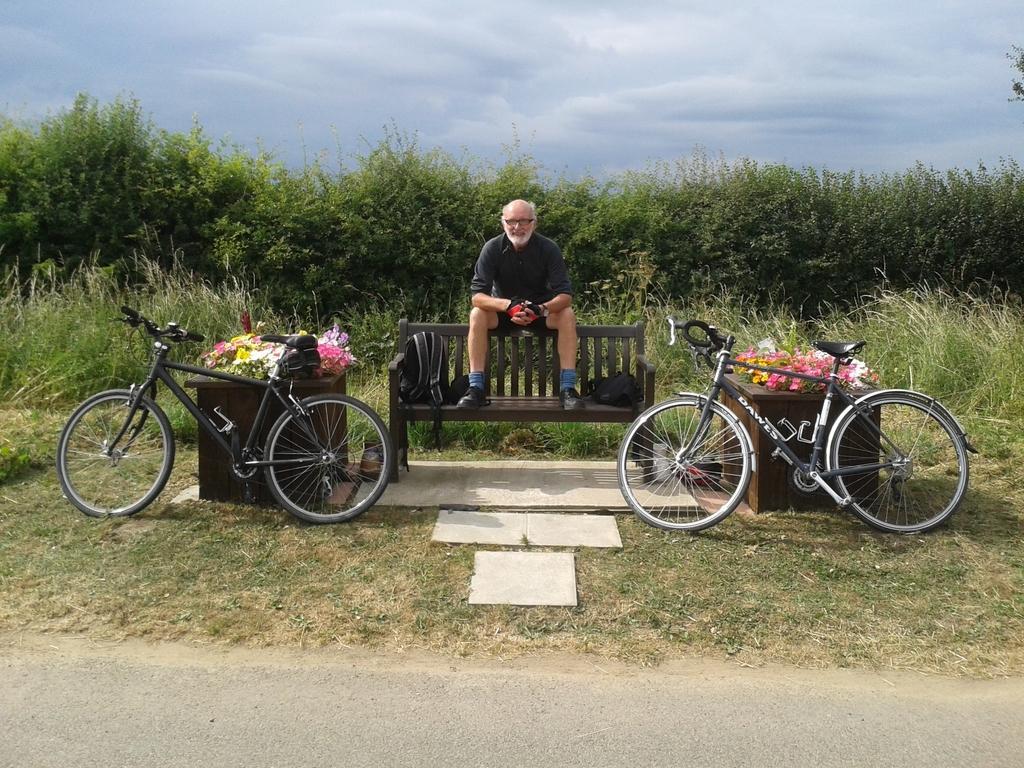Please provide a concise description of this image. In this image we can see a man sitting on a bench containing bags. we can also see cycles and some flowers placed on the table. On the backside we can see some plants, grass, trees and the sky which looks cloudy. 